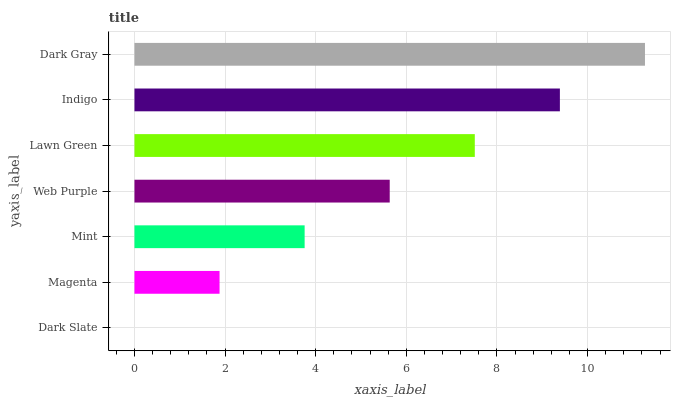Is Dark Slate the minimum?
Answer yes or no. Yes. Is Dark Gray the maximum?
Answer yes or no. Yes. Is Magenta the minimum?
Answer yes or no. No. Is Magenta the maximum?
Answer yes or no. No. Is Magenta greater than Dark Slate?
Answer yes or no. Yes. Is Dark Slate less than Magenta?
Answer yes or no. Yes. Is Dark Slate greater than Magenta?
Answer yes or no. No. Is Magenta less than Dark Slate?
Answer yes or no. No. Is Web Purple the high median?
Answer yes or no. Yes. Is Web Purple the low median?
Answer yes or no. Yes. Is Indigo the high median?
Answer yes or no. No. Is Indigo the low median?
Answer yes or no. No. 